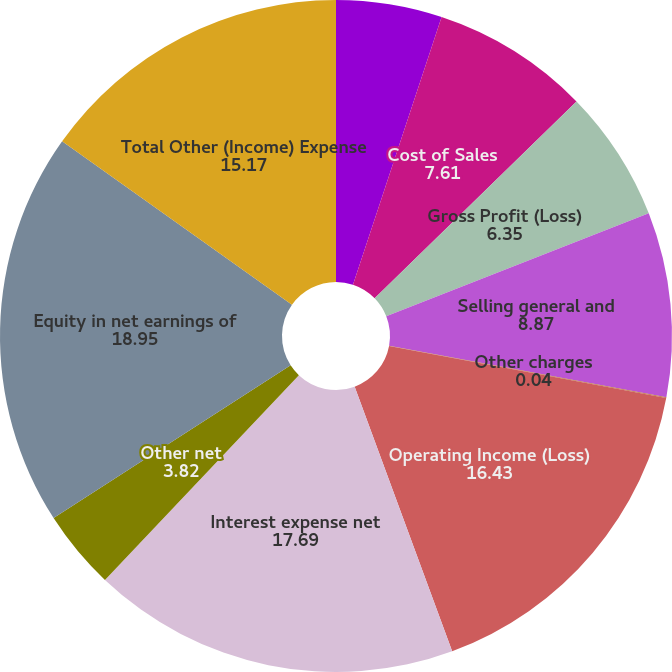Convert chart. <chart><loc_0><loc_0><loc_500><loc_500><pie_chart><fcel>Net Sales<fcel>Cost of Sales<fcel>Gross Profit (Loss)<fcel>Selling general and<fcel>Other charges<fcel>Operating Income (Loss)<fcel>Interest expense net<fcel>Other net<fcel>Equity in net earnings of<fcel>Total Other (Income) Expense<nl><fcel>5.09%<fcel>7.61%<fcel>6.35%<fcel>8.87%<fcel>0.04%<fcel>16.43%<fcel>17.69%<fcel>3.82%<fcel>18.95%<fcel>15.17%<nl></chart> 